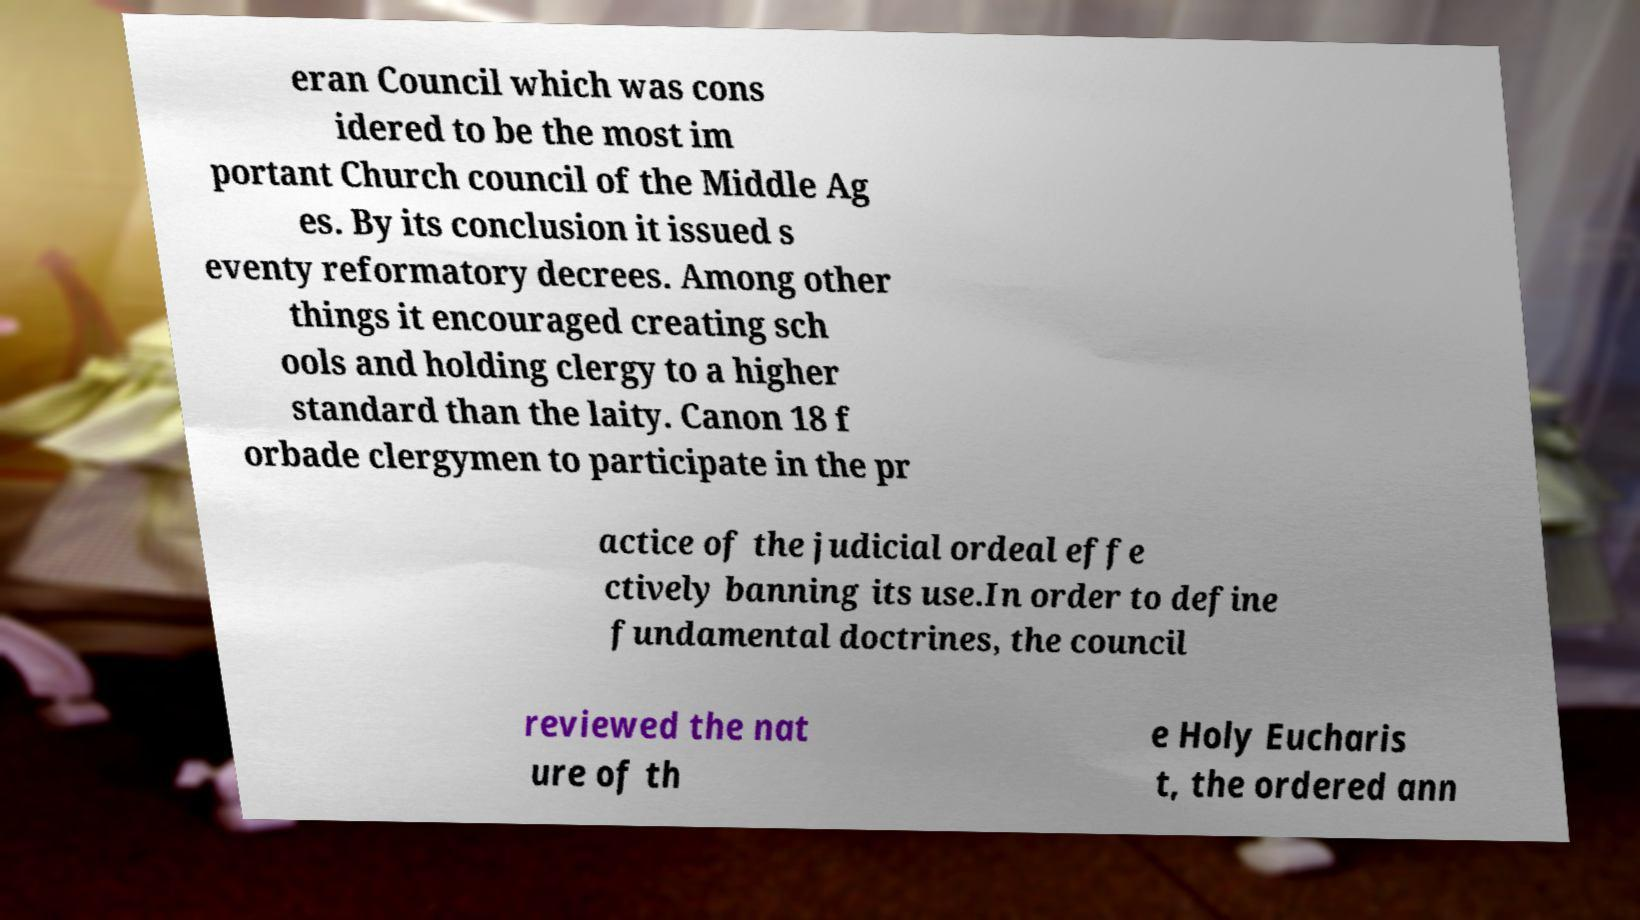Please read and relay the text visible in this image. What does it say? eran Council which was cons idered to be the most im portant Church council of the Middle Ag es. By its conclusion it issued s eventy reformatory decrees. Among other things it encouraged creating sch ools and holding clergy to a higher standard than the laity. Canon 18 f orbade clergymen to participate in the pr actice of the judicial ordeal effe ctively banning its use.In order to define fundamental doctrines, the council reviewed the nat ure of th e Holy Eucharis t, the ordered ann 